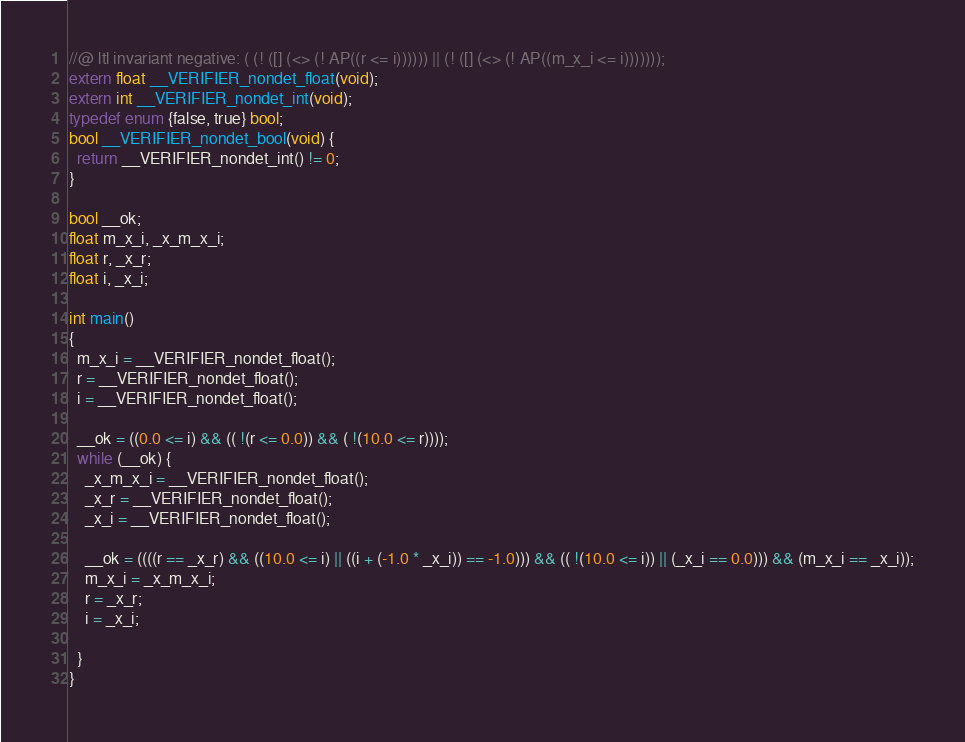<code> <loc_0><loc_0><loc_500><loc_500><_C_>//@ ltl invariant negative: ( (! ([] (<> (! AP((r <= i)))))) || (! ([] (<> (! AP((m_x_i <= i)))))));
extern float __VERIFIER_nondet_float(void);
extern int __VERIFIER_nondet_int(void);
typedef enum {false, true} bool;
bool __VERIFIER_nondet_bool(void) {
  return __VERIFIER_nondet_int() != 0;
}

bool __ok;
float m_x_i, _x_m_x_i;
float r, _x_r;
float i, _x_i;

int main()
{
  m_x_i = __VERIFIER_nondet_float();
  r = __VERIFIER_nondet_float();
  i = __VERIFIER_nondet_float();

  __ok = ((0.0 <= i) && (( !(r <= 0.0)) && ( !(10.0 <= r))));
  while (__ok) {
    _x_m_x_i = __VERIFIER_nondet_float();
    _x_r = __VERIFIER_nondet_float();
    _x_i = __VERIFIER_nondet_float();

    __ok = ((((r == _x_r) && ((10.0 <= i) || ((i + (-1.0 * _x_i)) == -1.0))) && (( !(10.0 <= i)) || (_x_i == 0.0))) && (m_x_i == _x_i));
    m_x_i = _x_m_x_i;
    r = _x_r;
    i = _x_i;

  }
}
</code> 